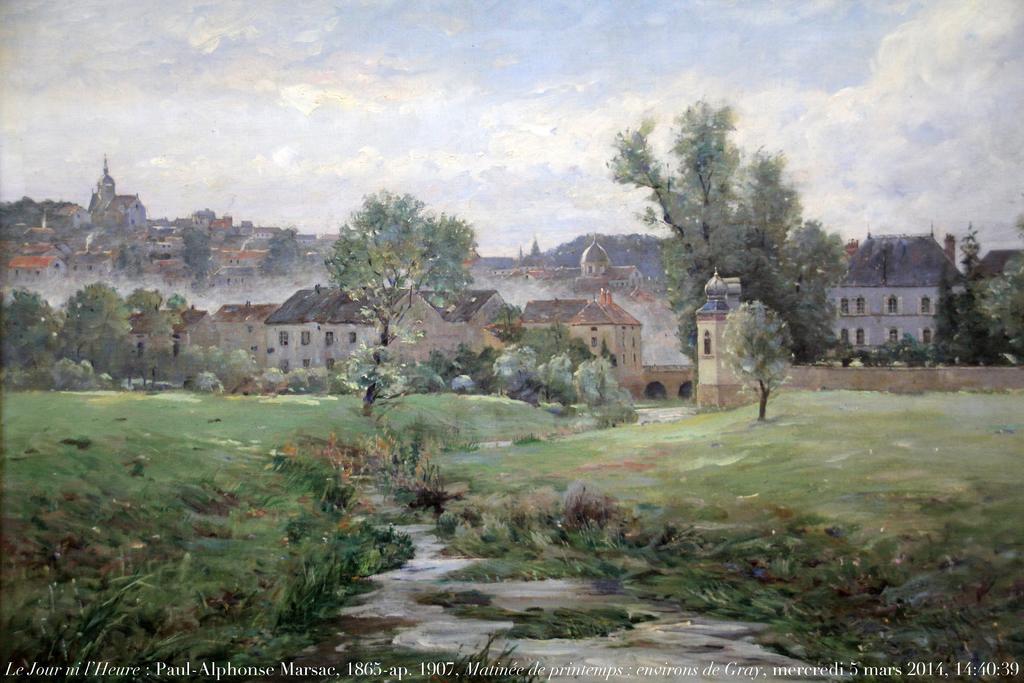How would you summarize this image in a sentence or two? In the foreground of this painted image, there is a water and grass. In the background, there are few buildings, trees and the sky. 